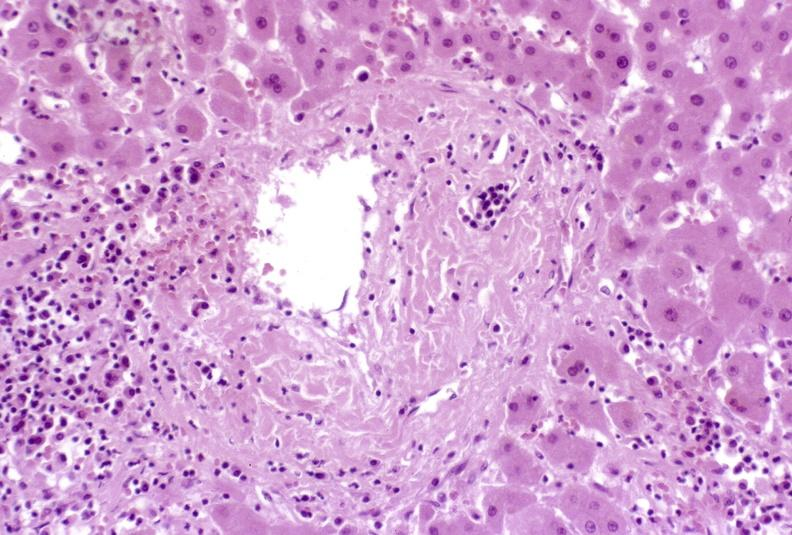what is present?
Answer the question using a single word or phrase. Hepatobiliary 